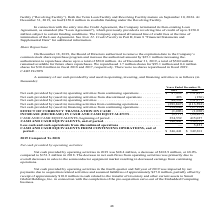According to Advanced Energy's financial document, What did the Board of Directors authorize in 2019? Based on the financial document, the answer is to remove the expiration date to the Company’s common stock share repurchase program and increase the authorized amount by $25.1 million increasing the authorization to repurchase shares up to a total of $50.0 million.. Also, What was the Net cash provided by (used in) operating activities from continuing operations in 2019? According to the financial document, $47,899 (in thousands). The relevant text states: "erating activities from continuing operations . $ 47,899 $ 151,427 Net cash provided by (used in) operating activities from discontinued operations . 493 (1..." Also, What does the table show? summary of our cash provided by and used in operating, investing, and financing activities. The document states: "A summary of our cash provided by and used in operating, investing, and financing activities is as follows (in thousands):..." Also, can you calculate: What was the change in Net cash provided by (used in) operating activities from continuing operations between 2018 and 2019? Based on the calculation: $47,899-$151,427, the result is -103528 (in thousands). This is based on the information: "erating activities from continuing operations . $ 47,899 $ 151,427 Net cash provided by (used in) operating activities from discontinued operations . 493 (1 ctivities from continuing operations . $ 47..." The key data points involved are: 151,427, 47,899. Also, can you calculate: What was the change in Net cash provided by (used in) operating activities between 2018 and 2019? Based on the calculation: 48,392-151,271, the result is -102879 (in thousands). This is based on the information: "ovided by (used in) operating activities . 48,392 151,271 cash provided by (used in) operating activities . 48,392 151,271..." The key data points involved are: 151,271, 48,392. Also, can you calculate: What was the percentage change in cash and cash equivalents from continuing operations at the end of the period between 2018 and 2019? To answer this question, I need to perform calculations using the financial data. The calculation is: ($346,441-$349,301)/$349,301, which equals -0.82 (percentage). This is based on the information: "15,037 CASH AND CASH EQUIVALENTS, end of period . 346,441 354,552 Less cash and cash equivalents from discontinued operations . — 5,251 ONTINUING OPERATIONS, end of period . $ 346,441 $ 349,301..." The key data points involved are: 346,441, 349,301. 